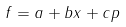Convert formula to latex. <formula><loc_0><loc_0><loc_500><loc_500>f = a + b x + c p</formula> 